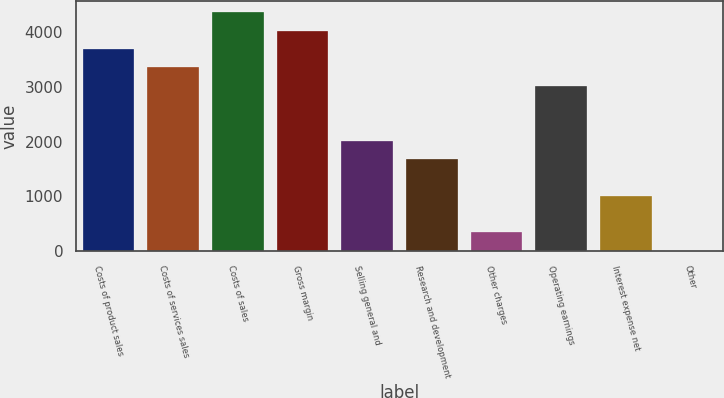Convert chart. <chart><loc_0><loc_0><loc_500><loc_500><bar_chart><fcel>Costs of product sales<fcel>Costs of services sales<fcel>Costs of sales<fcel>Gross margin<fcel>Selling general and<fcel>Research and development<fcel>Other charges<fcel>Operating earnings<fcel>Interest expense net<fcel>Other<nl><fcel>3690.6<fcel>3356<fcel>4359.8<fcel>4025.2<fcel>2017.6<fcel>1683<fcel>344.6<fcel>3021.4<fcel>1013.8<fcel>10<nl></chart> 